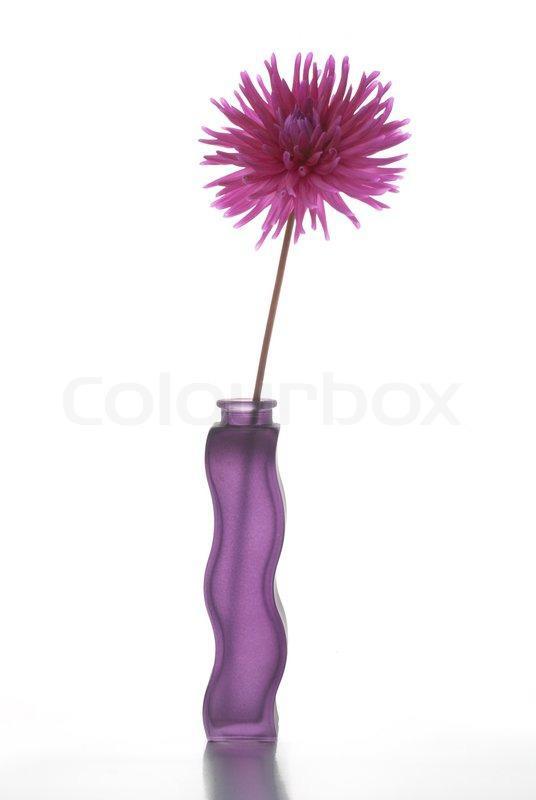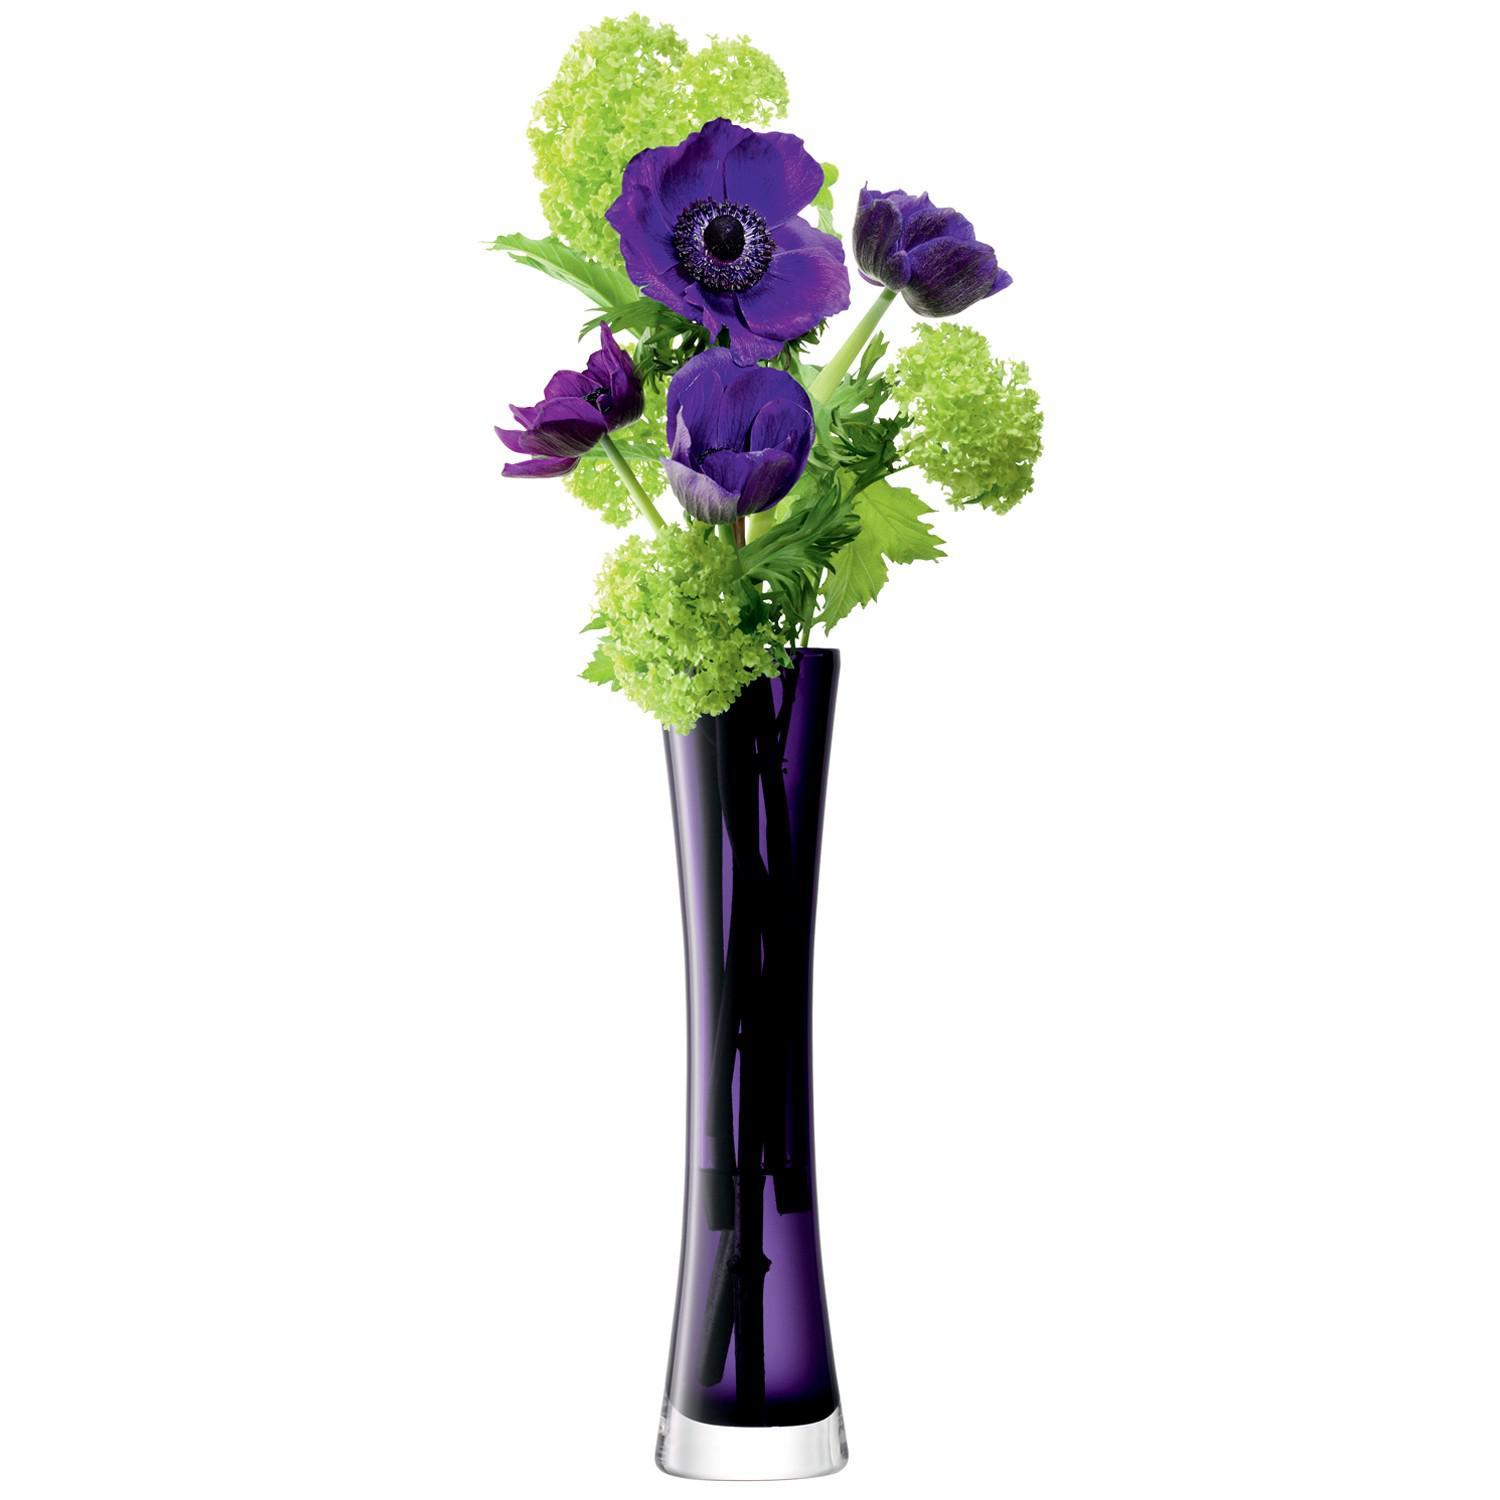The first image is the image on the left, the second image is the image on the right. Analyze the images presented: Is the assertion "There are exactly two clear glass vases." valid? Answer yes or no. No. The first image is the image on the left, the second image is the image on the right. For the images shown, is this caption "There are 2 vases." true? Answer yes or no. Yes. 